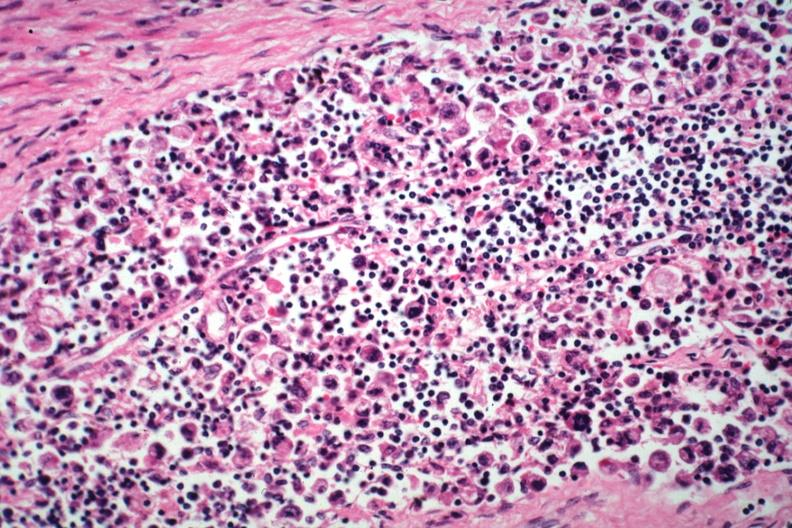s metastatic carcinoma present?
Answer the question using a single word or phrase. Yes 